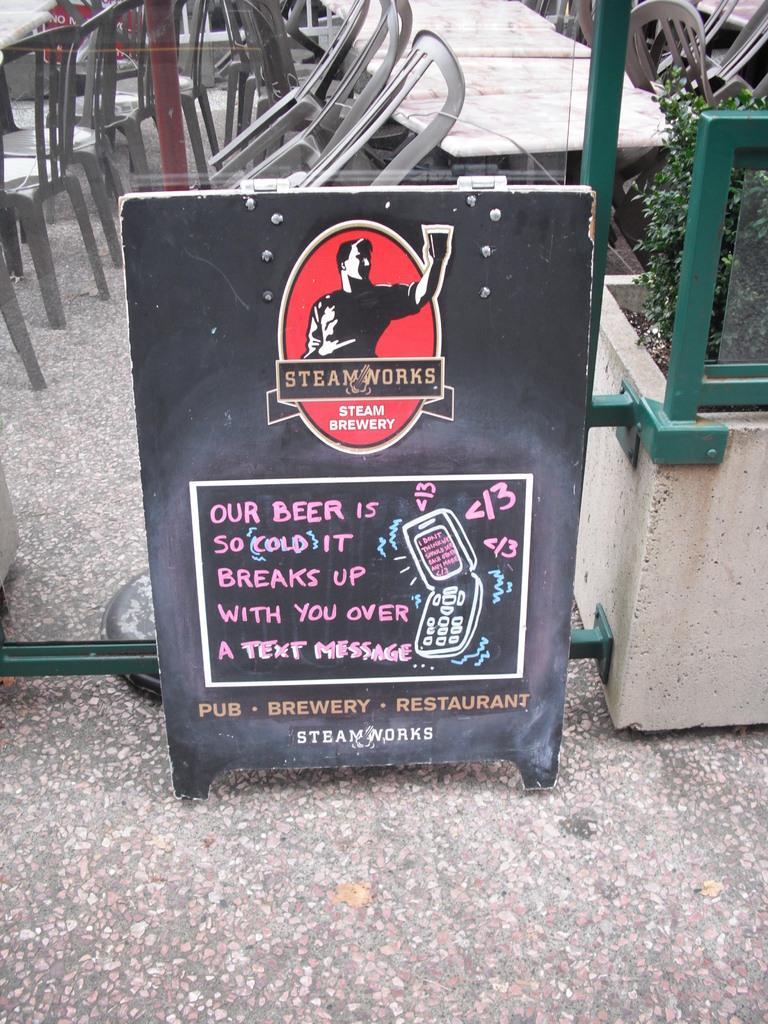Could you give a brief overview of what you see in this image? In this image there is a board on the floor. On the board there is some text and image of a mobile a person are on it. Behind the board there is glass wall. Behind it there are few chairs and tables are on the floor. Right side there is a pot having a plant in it. 